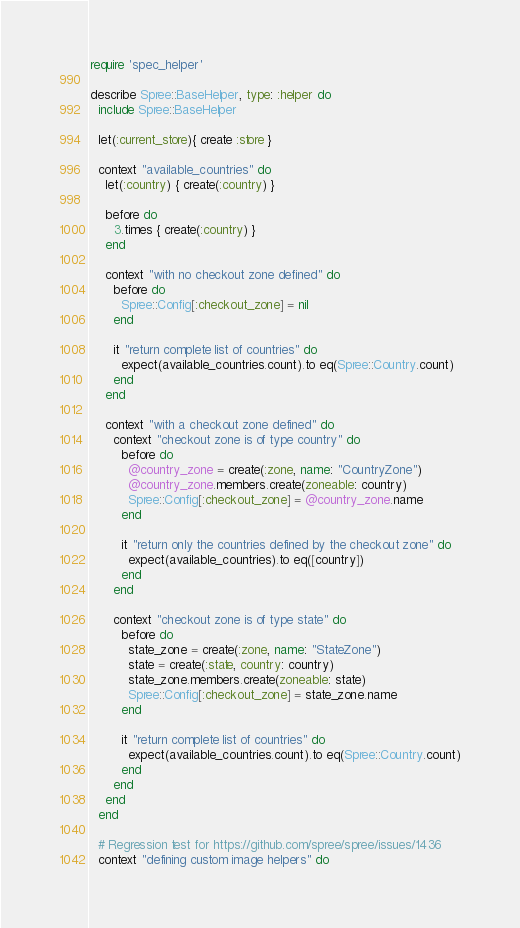<code> <loc_0><loc_0><loc_500><loc_500><_Ruby_>require 'spec_helper'

describe Spree::BaseHelper, type: :helper do
  include Spree::BaseHelper

  let(:current_store){ create :store }

  context "available_countries" do
    let(:country) { create(:country) }

    before do
      3.times { create(:country) }
    end

    context "with no checkout zone defined" do
      before do
        Spree::Config[:checkout_zone] = nil
      end

      it "return complete list of countries" do
        expect(available_countries.count).to eq(Spree::Country.count)
      end
    end

    context "with a checkout zone defined" do
      context "checkout zone is of type country" do
        before do
          @country_zone = create(:zone, name: "CountryZone")
          @country_zone.members.create(zoneable: country)
          Spree::Config[:checkout_zone] = @country_zone.name
        end

        it "return only the countries defined by the checkout zone" do
          expect(available_countries).to eq([country])
        end
      end

      context "checkout zone is of type state" do
        before do
          state_zone = create(:zone, name: "StateZone")
          state = create(:state, country: country)
          state_zone.members.create(zoneable: state)
          Spree::Config[:checkout_zone] = state_zone.name
        end

        it "return complete list of countries" do
          expect(available_countries.count).to eq(Spree::Country.count)
        end
      end
    end
  end

  # Regression test for https://github.com/spree/spree/issues/1436
  context "defining custom image helpers" do</code> 